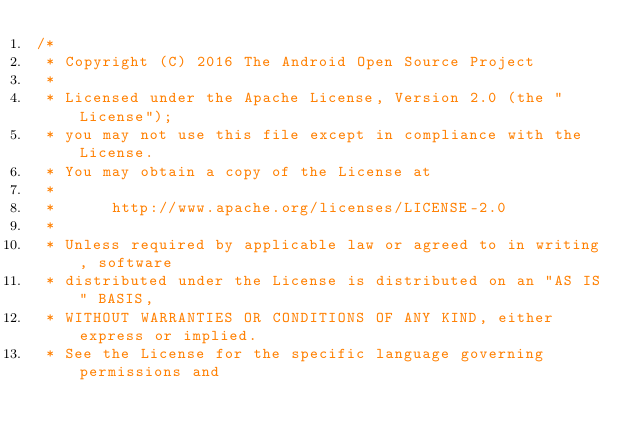Convert code to text. <code><loc_0><loc_0><loc_500><loc_500><_Java_>/*
 * Copyright (C) 2016 The Android Open Source Project
 *
 * Licensed under the Apache License, Version 2.0 (the "License");
 * you may not use this file except in compliance with the License.
 * You may obtain a copy of the License at
 *
 *      http://www.apache.org/licenses/LICENSE-2.0
 *
 * Unless required by applicable law or agreed to in writing, software
 * distributed under the License is distributed on an "AS IS" BASIS,
 * WITHOUT WARRANTIES OR CONDITIONS OF ANY KIND, either express or implied.
 * See the License for the specific language governing permissions and</code> 